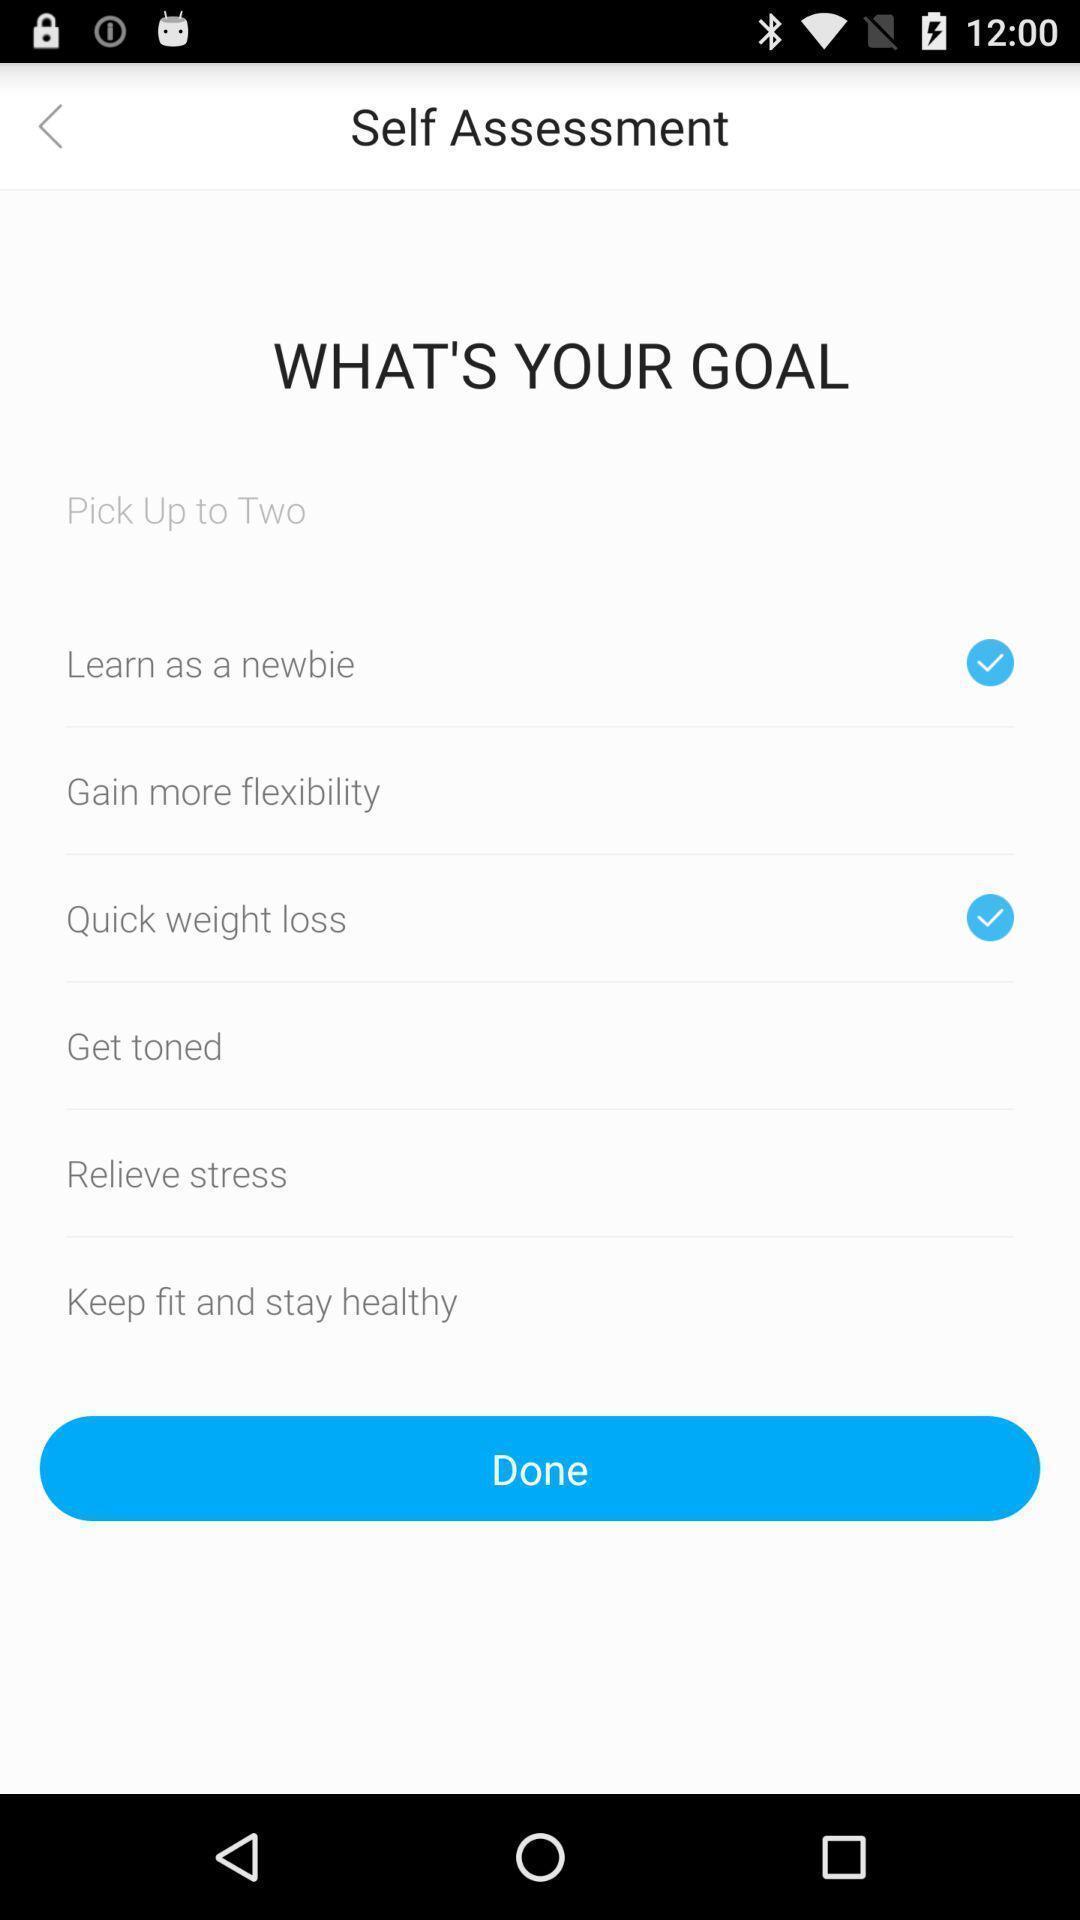What is the overall content of this screenshot? Self assessment of whats your goal. 